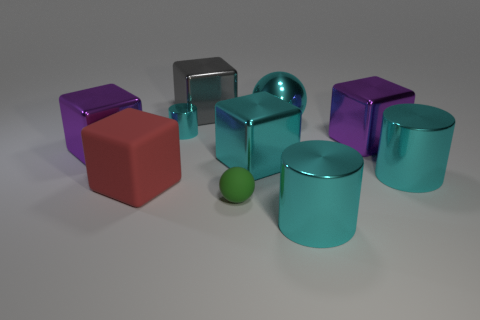Subtract all cyan shiny blocks. How many blocks are left? 4 Subtract 1 cylinders. How many cylinders are left? 2 Subtract all gray cubes. How many cubes are left? 4 Subtract all cylinders. How many objects are left? 7 Subtract all brown spheres. How many purple cubes are left? 2 Add 7 big matte things. How many big matte things are left? 8 Add 1 large purple objects. How many large purple objects exist? 3 Subtract 1 green spheres. How many objects are left? 9 Subtract all gray blocks. Subtract all yellow balls. How many blocks are left? 4 Subtract all big metallic balls. Subtract all metallic spheres. How many objects are left? 8 